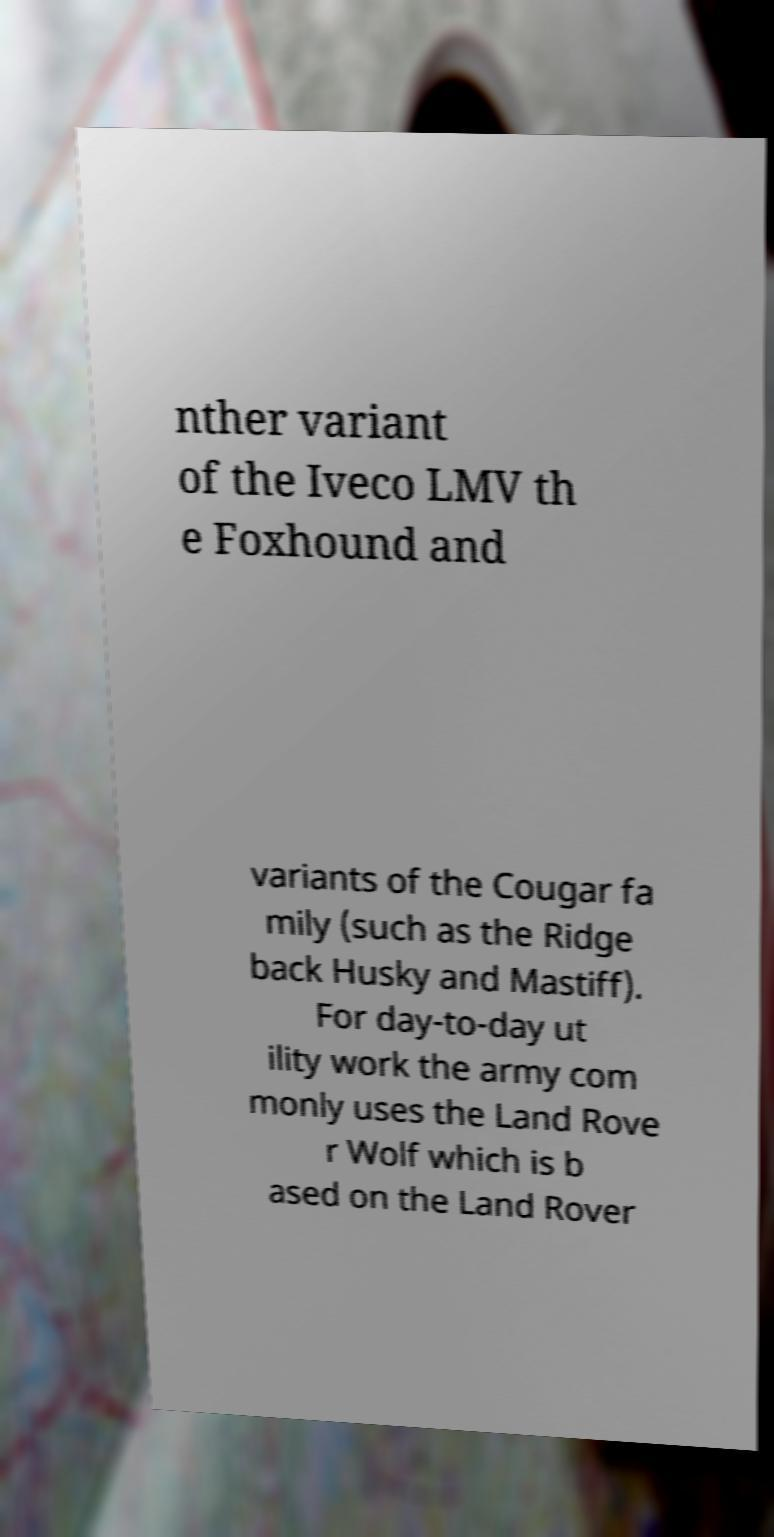I need the written content from this picture converted into text. Can you do that? nther variant of the Iveco LMV th e Foxhound and variants of the Cougar fa mily (such as the Ridge back Husky and Mastiff). For day-to-day ut ility work the army com monly uses the Land Rove r Wolf which is b ased on the Land Rover 